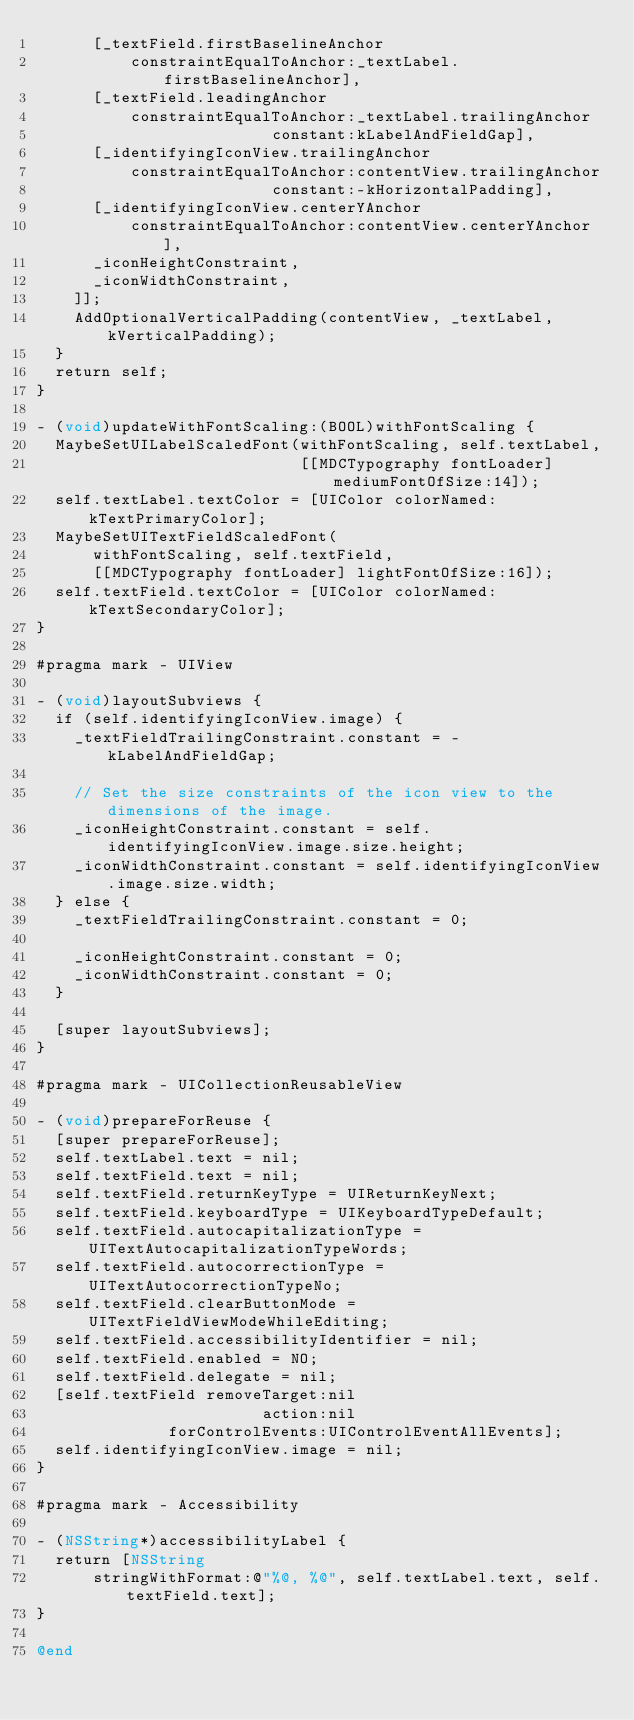<code> <loc_0><loc_0><loc_500><loc_500><_ObjectiveC_>      [_textField.firstBaselineAnchor
          constraintEqualToAnchor:_textLabel.firstBaselineAnchor],
      [_textField.leadingAnchor
          constraintEqualToAnchor:_textLabel.trailingAnchor
                         constant:kLabelAndFieldGap],
      [_identifyingIconView.trailingAnchor
          constraintEqualToAnchor:contentView.trailingAnchor
                         constant:-kHorizontalPadding],
      [_identifyingIconView.centerYAnchor
          constraintEqualToAnchor:contentView.centerYAnchor],
      _iconHeightConstraint,
      _iconWidthConstraint,
    ]];
    AddOptionalVerticalPadding(contentView, _textLabel, kVerticalPadding);
  }
  return self;
}

- (void)updateWithFontScaling:(BOOL)withFontScaling {
  MaybeSetUILabelScaledFont(withFontScaling, self.textLabel,
                            [[MDCTypography fontLoader] mediumFontOfSize:14]);
  self.textLabel.textColor = [UIColor colorNamed:kTextPrimaryColor];
  MaybeSetUITextFieldScaledFont(
      withFontScaling, self.textField,
      [[MDCTypography fontLoader] lightFontOfSize:16]);
  self.textField.textColor = [UIColor colorNamed:kTextSecondaryColor];
}

#pragma mark - UIView

- (void)layoutSubviews {
  if (self.identifyingIconView.image) {
    _textFieldTrailingConstraint.constant = -kLabelAndFieldGap;

    // Set the size constraints of the icon view to the dimensions of the image.
    _iconHeightConstraint.constant = self.identifyingIconView.image.size.height;
    _iconWidthConstraint.constant = self.identifyingIconView.image.size.width;
  } else {
    _textFieldTrailingConstraint.constant = 0;

    _iconHeightConstraint.constant = 0;
    _iconWidthConstraint.constant = 0;
  }

  [super layoutSubviews];
}

#pragma mark - UICollectionReusableView

- (void)prepareForReuse {
  [super prepareForReuse];
  self.textLabel.text = nil;
  self.textField.text = nil;
  self.textField.returnKeyType = UIReturnKeyNext;
  self.textField.keyboardType = UIKeyboardTypeDefault;
  self.textField.autocapitalizationType = UITextAutocapitalizationTypeWords;
  self.textField.autocorrectionType = UITextAutocorrectionTypeNo;
  self.textField.clearButtonMode = UITextFieldViewModeWhileEditing;
  self.textField.accessibilityIdentifier = nil;
  self.textField.enabled = NO;
  self.textField.delegate = nil;
  [self.textField removeTarget:nil
                        action:nil
              forControlEvents:UIControlEventAllEvents];
  self.identifyingIconView.image = nil;
}

#pragma mark - Accessibility

- (NSString*)accessibilityLabel {
  return [NSString
      stringWithFormat:@"%@, %@", self.textLabel.text, self.textField.text];
}

@end
</code> 